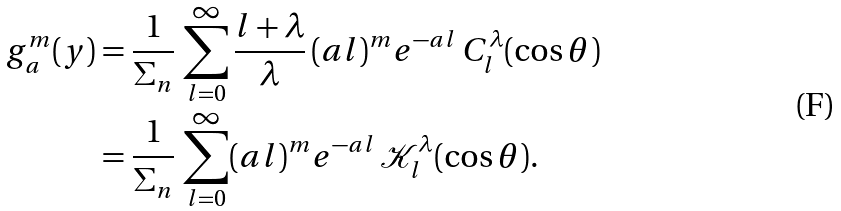<formula> <loc_0><loc_0><loc_500><loc_500>g _ { a } ^ { m } ( y ) & = \frac { 1 } { \Sigma _ { n } } \, \sum _ { l = 0 } ^ { \infty } \frac { l + \lambda } { \lambda } \, ( a l ) ^ { m } e ^ { - a l } \, C _ { l } ^ { \lambda } ( \cos \theta ) \\ & = \frac { 1 } { \Sigma _ { n } } \, \sum _ { l = 0 } ^ { \infty } ( a l ) ^ { m } e ^ { - a l } \, \mathcal { K } _ { l } ^ { \lambda } ( \cos \theta ) .</formula> 